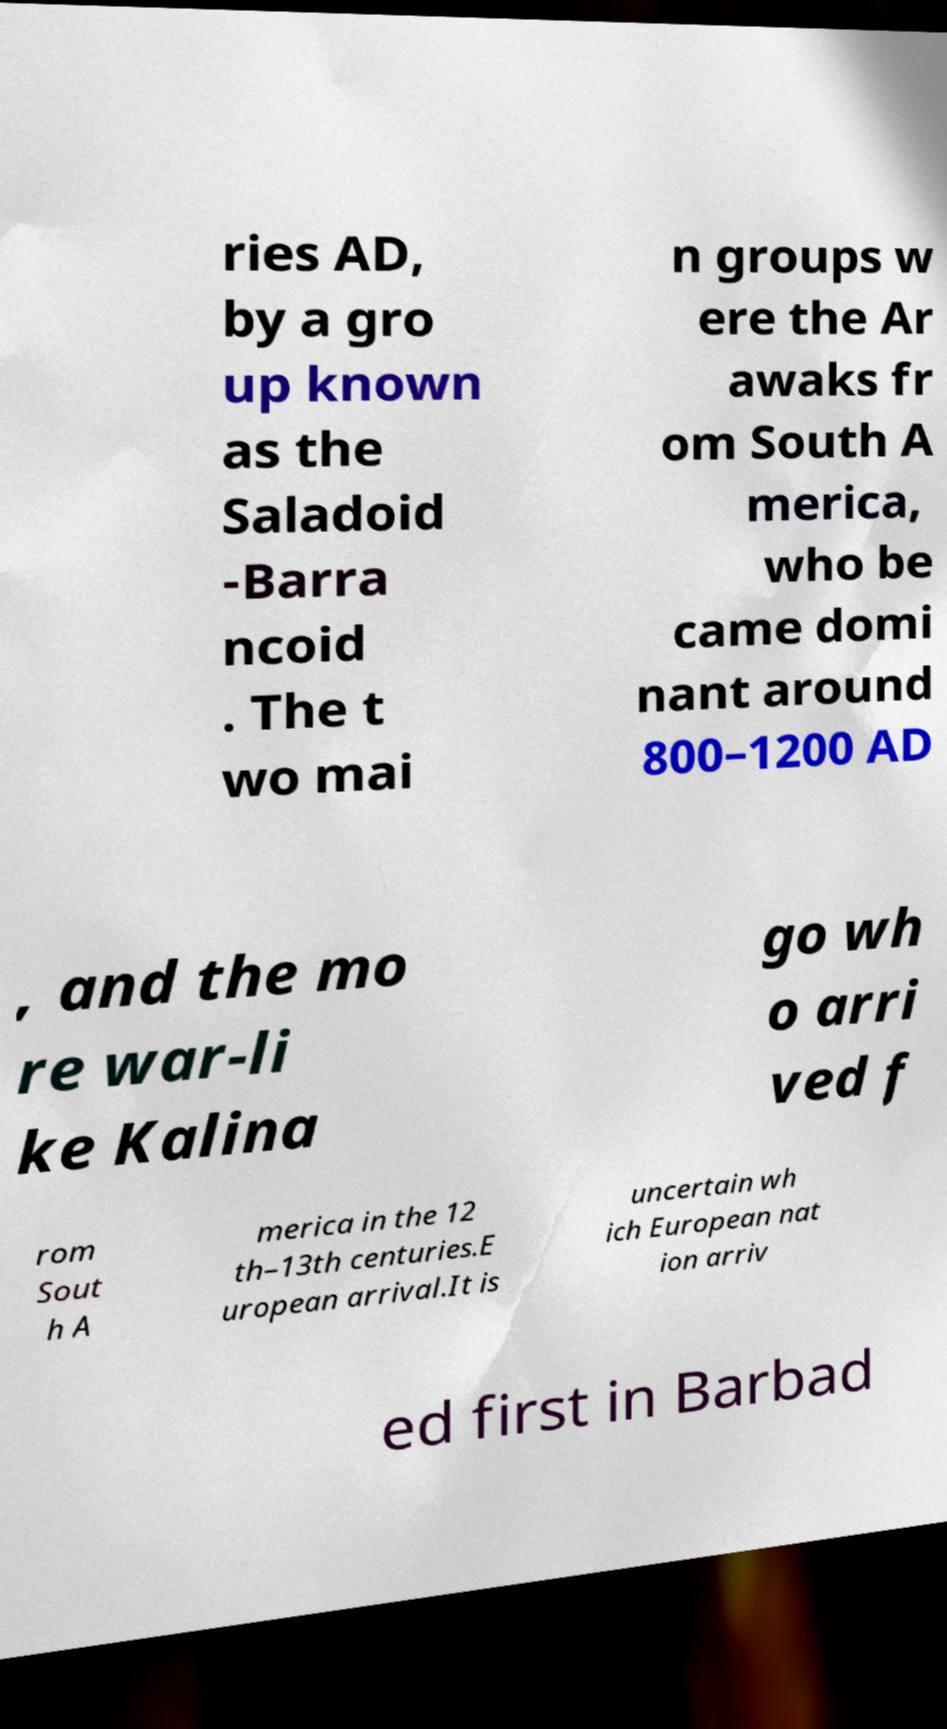Please identify and transcribe the text found in this image. ries AD, by a gro up known as the Saladoid -Barra ncoid . The t wo mai n groups w ere the Ar awaks fr om South A merica, who be came domi nant around 800–1200 AD , and the mo re war-li ke Kalina go wh o arri ved f rom Sout h A merica in the 12 th–13th centuries.E uropean arrival.It is uncertain wh ich European nat ion arriv ed first in Barbad 